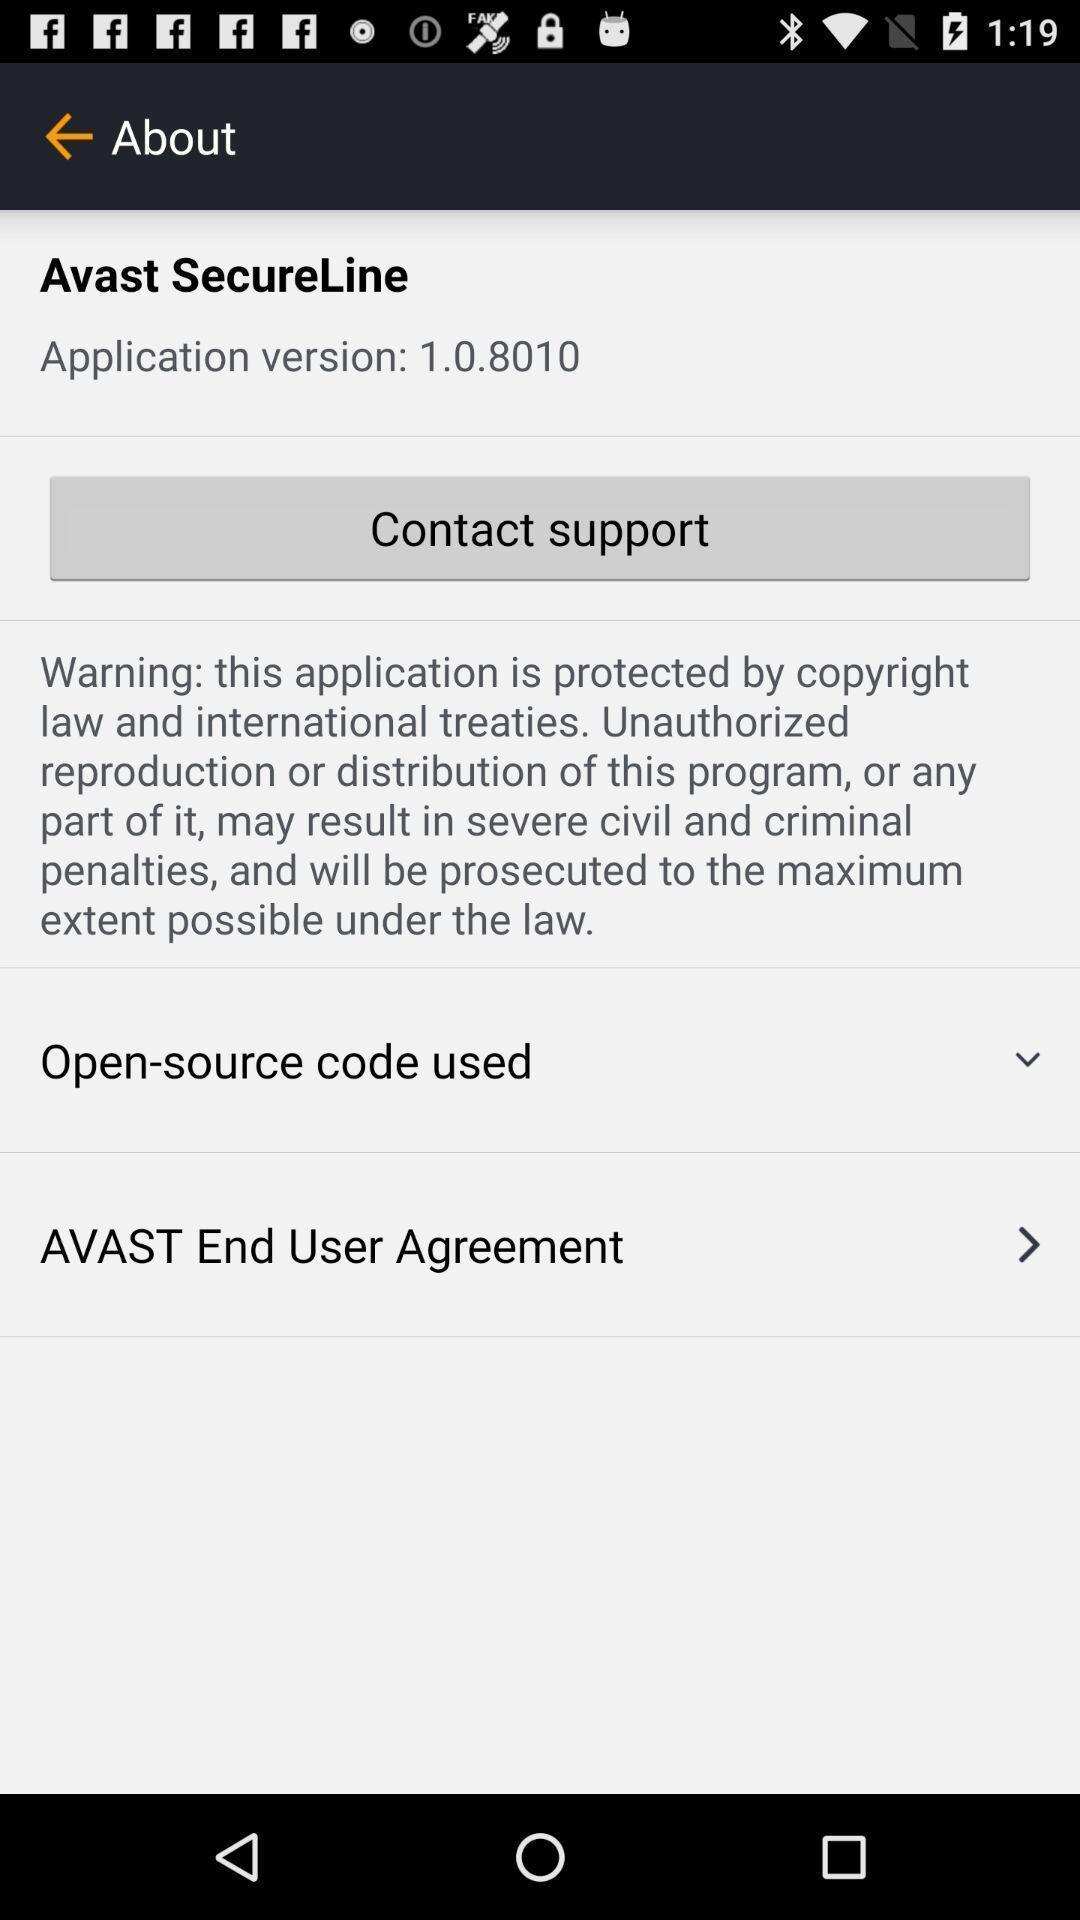Give me a summary of this screen capture. Page displaying security and other informations about an application. 